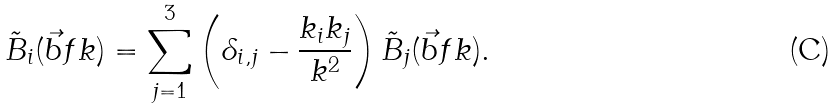<formula> <loc_0><loc_0><loc_500><loc_500>\tilde { B } _ { i } ( \vec { b } f { k } ) = \sum _ { j = 1 } ^ { 3 } \left ( \delta _ { i , j } - \frac { k _ { i } k _ { j } } { k ^ { 2 } } \right ) \tilde { B } _ { j } ( \vec { b } f { k } ) .</formula> 